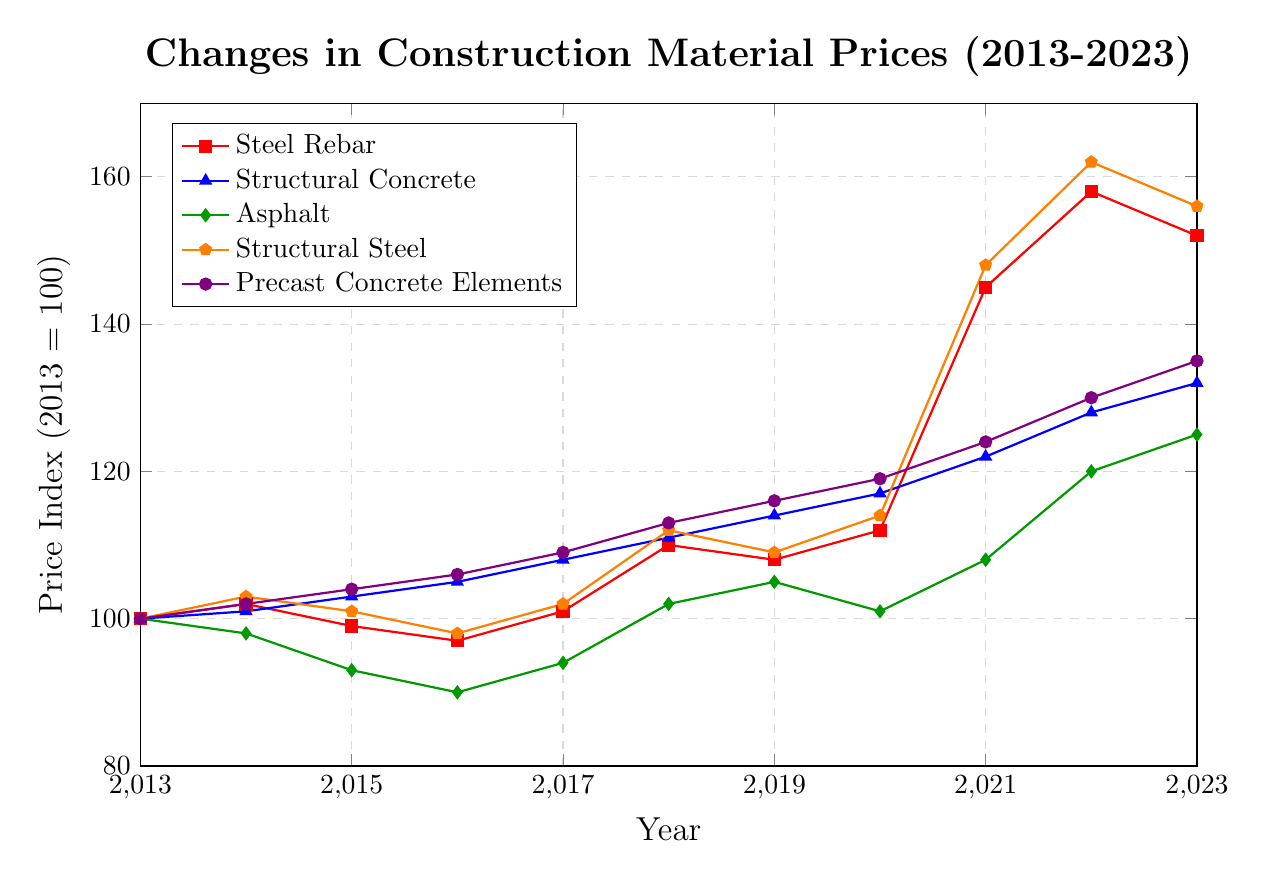What material experienced the highest price increase between 2013 and 2023? To find the material with the highest price increase, we subtract the 2013 value from the 2023 value for each material. The increases are: 
- Steel Rebar: 152 - 100 = 52
- Structural Concrete: 132 - 100 = 32
- Asphalt: 125 - 100 = 25
- Structural Steel: 156 - 100 = 56
- Precast Concrete Elements: 135 - 100 = 35
Structural Steel has the highest increase of 56.
Answer: Structural Steel Which material had the biggest price drop between 2015 and 2016? We check the difference between the prices in 2015 and 2016 for each material and find the one with the largest negative value.
- Steel Rebar: 99 - 97 = 2
- Structural Concrete: 103 - 105 = -2
- Asphalt: 93 - 90 = 3
- Structural Steel: 101 - 98 = 3
- Precast Concrete Elements: 104 - 106 = -2
The biggest drop is for both Structural Concrete and Precast Concrete Elements, both having a decrease of 2.
Answer: Structural Concrete and Precast Concrete Elements In which year did the price of Asphalt surpass the price of Steel Rebar for the first time? We compare the yearly values for Asphalt and Steel Rebar. Starting from 2013 to 2023:
- 2013: Asphalt (100) < Steel Rebar (100)
- 2014: Asphalt (98) < Steel Rebar (102)
- 2015: Asphalt (93) < Steel Rebar (99)
- 2016: Asphalt (90) < Steel Rebar (97)
- 2017: Asphalt (94) < Steel Rebar (101)
- 2018: Asphalt (102) < Steel Rebar (110)
- 2019: Asphalt (105) < Steel Rebar (108)
- 2020: Asphalt (101) < Steel Rebar (112)
- 2021: Asphalt (108) < Steel Rebar (145)
- 2022: Asphalt (120) < Steel Rebar (158)
- 2023: Asphalt (125) < Steel Rebar (152)
Asphalt never surpasses the price of Steel Rebar in the given years.
Answer: Never How many times did the price of Precast Concrete Elements increase between two consecutive years? We look for increases from one year to the next and count them:
- 2014: 102 > 100 (increase)
- 2015: 104 > 102 (increase)
- 2016: 106 > 104 (increase)
- 2017: 109 > 106 (increase)
- 2018: 113 > 109 (increase)
- 2019: 116 > 113 (increase)
- 2020: 119 > 116 (increase)
- 2021: 124 > 119 (increase)
- 2022: 130 > 124 (increase)
- 2023: 135 > 130 (increase)
There are increases in every year from 2014 to 2023.
Answer: 10 Which material had the least fluctuation in price over the decade? We calculate the range (difference between the highest and lowest values) for each material:
- Steel Rebar: 158 - 97 = 61
- Structural Concrete: 132 - 100 = 32
- Asphalt: 125 - 90 = 35
- Structural Steel: 162 - 98 = 64
- Precast Concrete Elements: 135 - 100 = 35
Structural Concrete had the smallest fluctuation with a range of 32.
Answer: Structural Concrete 